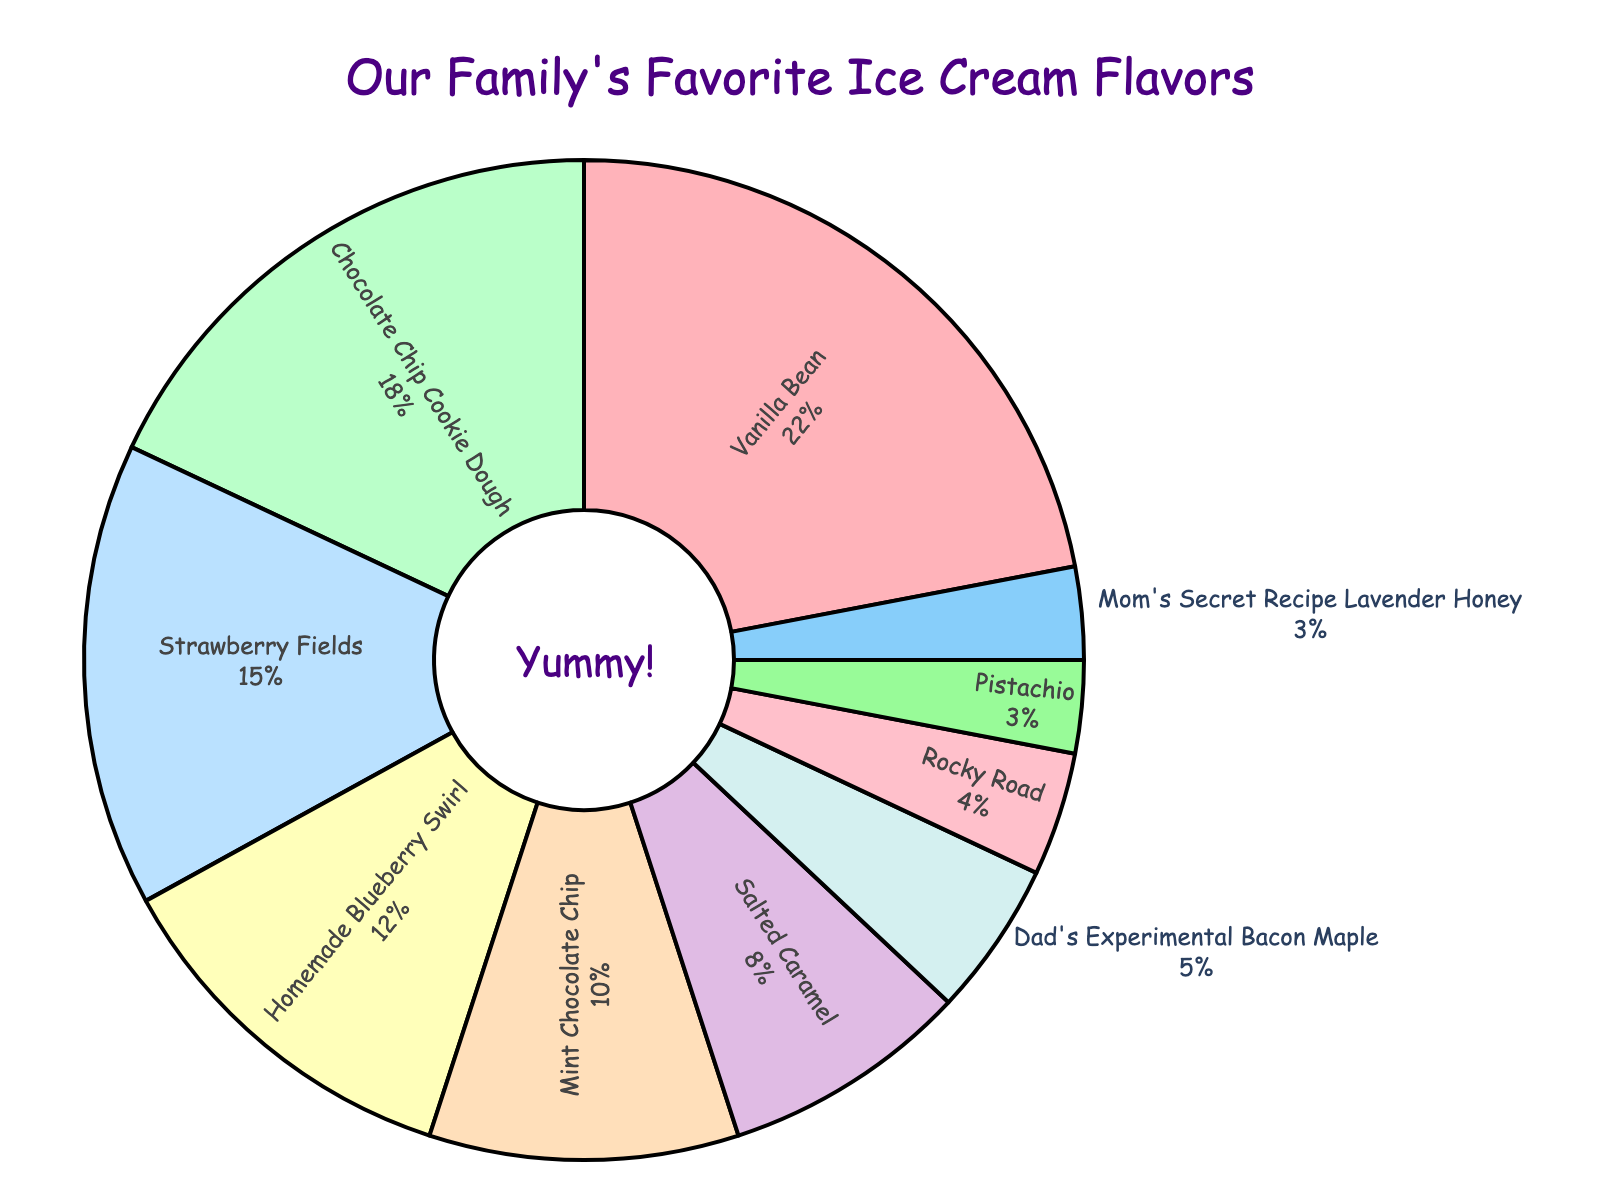Which flavor has the highest percentage of favorite votes? Look at the pie chart and locate the section with the largest size and label. The label "Vanilla Bean" has the largest segment.
Answer: Vanilla Bean Which two flavors combined have a total percentage of 33%? Check the individual percentages and find two flavors that add up to 33%. Chocolate Chip Cookie Dough (18%) and Strawberry Fields (15%) together sum up to 33%.
Answer: Chocolate Chip Cookie Dough and Strawberry Fields How many store-bought flavors have a percentage higher than 10%? Identify the flavors with percentages higher than 10%. Count these and exclude homemade flavors. Vanilla Bean (22%), Chocolate Chip Cookie Dough (18%), Strawberry Fields (15%) and Mint Chocolate Chip (10%) are the store-bought flavors above 10%, but Mint Chocolate Chip is exactly 10%. So, the count is 3.
Answer: 3 Which flavors have an equal percentage share of 3%? Find the segments with a label showing 3%. Both Pistachio and Mom's Secret Recipe Lavender Honey have 3%.
Answer: Pistachio and Mom's Secret Recipe Lavender Honey Is Homemade Blueberry Swirl more popular than Mint Chocolate Chip? By how much? Compare the percentages of Homemade Blueberry Swirl (12%) and Mint Chocolate Chip (10%). Determine the difference. 12% - 10% = 2%.
Answer: Yes, by 2% Which flavor section is the smallest in the chart? Determine which section of the pie chart occupies the smallest area. Rocky Road has 4%, Dad’s Experimental Bacon Maple has 5%, but the smallest are Pistachio and Mom's Secret Recipe Lavender Honey with 3%. Pick one based on observation. Since they both are equal, either can be an answer.
Answer: Pistachio or Mom's Secret Recipe Lavender Honey What is the total percentage of homemade flavors in the chart? Sum up the percentages of homemade flavors: Homemade Blueberry Swirl (12%) and Mom's Secret Recipe Lavender Honey (3%) which gives 15%. Include Dad's Experimental Bacon Maple (5%) to reach 20%.
Answer: 20% Which flavor holds exactly a 10% share, and what color represents it on the chart? Locate the flavor with a 10% label. Mint Chocolate Chip has 10%, and its segment is light green.
Answer: Mint Chocolate Chip, light green What is the percentage difference between the most and least popular flavors? Calculate the difference between Vanilla Bean (22%) as most popular and Pistachio or Mom's Secret Recipe Lavender Honey (3%) as least popular. 22% - 3% = 19%.
Answer: 19% What percentage of the total chart is comprised of the top three favorite ice cream flavors? Add the percentages for Vanilla Bean (22%), Chocolate Chip Cookie Dough (18%), and Strawberry Fields (15%). 22% + 18% + 15% = 55%.
Answer: 55% 